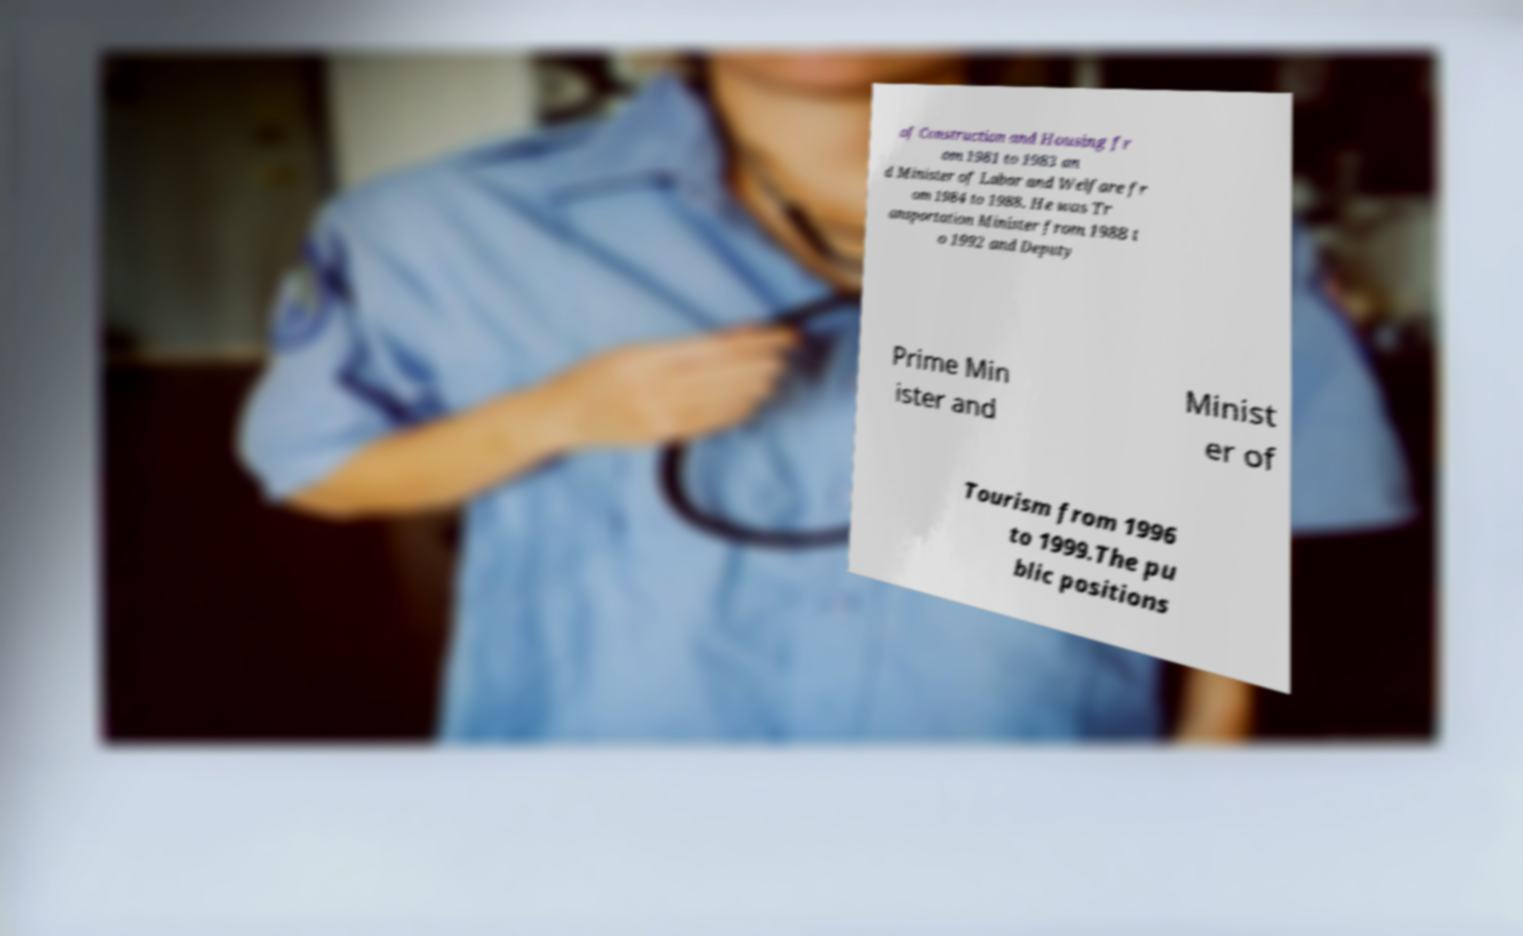Can you accurately transcribe the text from the provided image for me? of Construction and Housing fr om 1981 to 1983 an d Minister of Labor and Welfare fr om 1984 to 1988. He was Tr ansportation Minister from 1988 t o 1992 and Deputy Prime Min ister and Minist er of Tourism from 1996 to 1999.The pu blic positions 